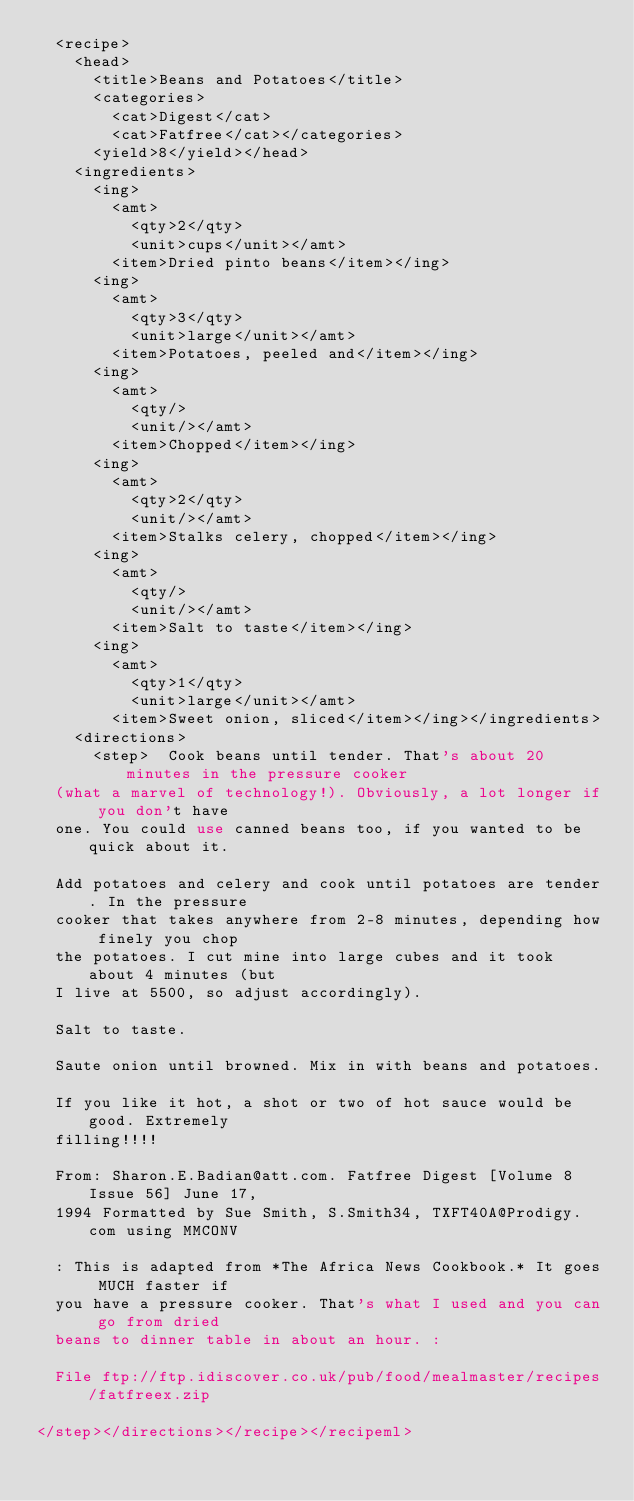<code> <loc_0><loc_0><loc_500><loc_500><_XML_>  <recipe>
    <head>
      <title>Beans and Potatoes</title>
      <categories>
        <cat>Digest</cat>
        <cat>Fatfree</cat></categories>
      <yield>8</yield></head>
    <ingredients>
      <ing>
        <amt>
          <qty>2</qty>
          <unit>cups</unit></amt>
        <item>Dried pinto beans</item></ing>
      <ing>
        <amt>
          <qty>3</qty>
          <unit>large</unit></amt>
        <item>Potatoes, peeled and</item></ing>
      <ing>
        <amt>
          <qty/>
          <unit/></amt>
        <item>Chopped</item></ing>
      <ing>
        <amt>
          <qty>2</qty>
          <unit/></amt>
        <item>Stalks celery, chopped</item></ing>
      <ing>
        <amt>
          <qty/>
          <unit/></amt>
        <item>Salt to taste</item></ing>
      <ing>
        <amt>
          <qty>1</qty>
          <unit>large</unit></amt>
        <item>Sweet onion, sliced</item></ing></ingredients>
    <directions>
      <step>  Cook beans until tender. That's about 20 minutes in the pressure cooker
  (what a marvel of technology!). Obviously, a lot longer if you don't have
  one. You could use canned beans too, if you wanted to be quick about it.
  
  Add potatoes and celery and cook until potatoes are tender. In the pressure
  cooker that takes anywhere from 2-8 minutes, depending how finely you chop
  the potatoes. I cut mine into large cubes and it took about 4 minutes (but
  I live at 5500, so adjust accordingly).
  
  Salt to taste.
  
  Saute onion until browned. Mix in with beans and potatoes.
  
  If you like it hot, a shot or two of hot sauce would be good. Extremely
  filling!!!!
  
  From: Sharon.E.Badian@att.com. Fatfree Digest [Volume 8 Issue 56] June 17,
  1994 Formatted by Sue Smith, S.Smith34, TXFT40A@Prodigy.com using MMCONV
  
  : This is adapted from *The Africa News Cookbook.* It goes MUCH faster if
  you have a pressure cooker. That's what I used and you can go from dried
  beans to dinner table in about an hour. :
  
  File ftp://ftp.idiscover.co.uk/pub/food/mealmaster/recipes/fatfreex.zip
 
</step></directions></recipe></recipeml>
</code> 